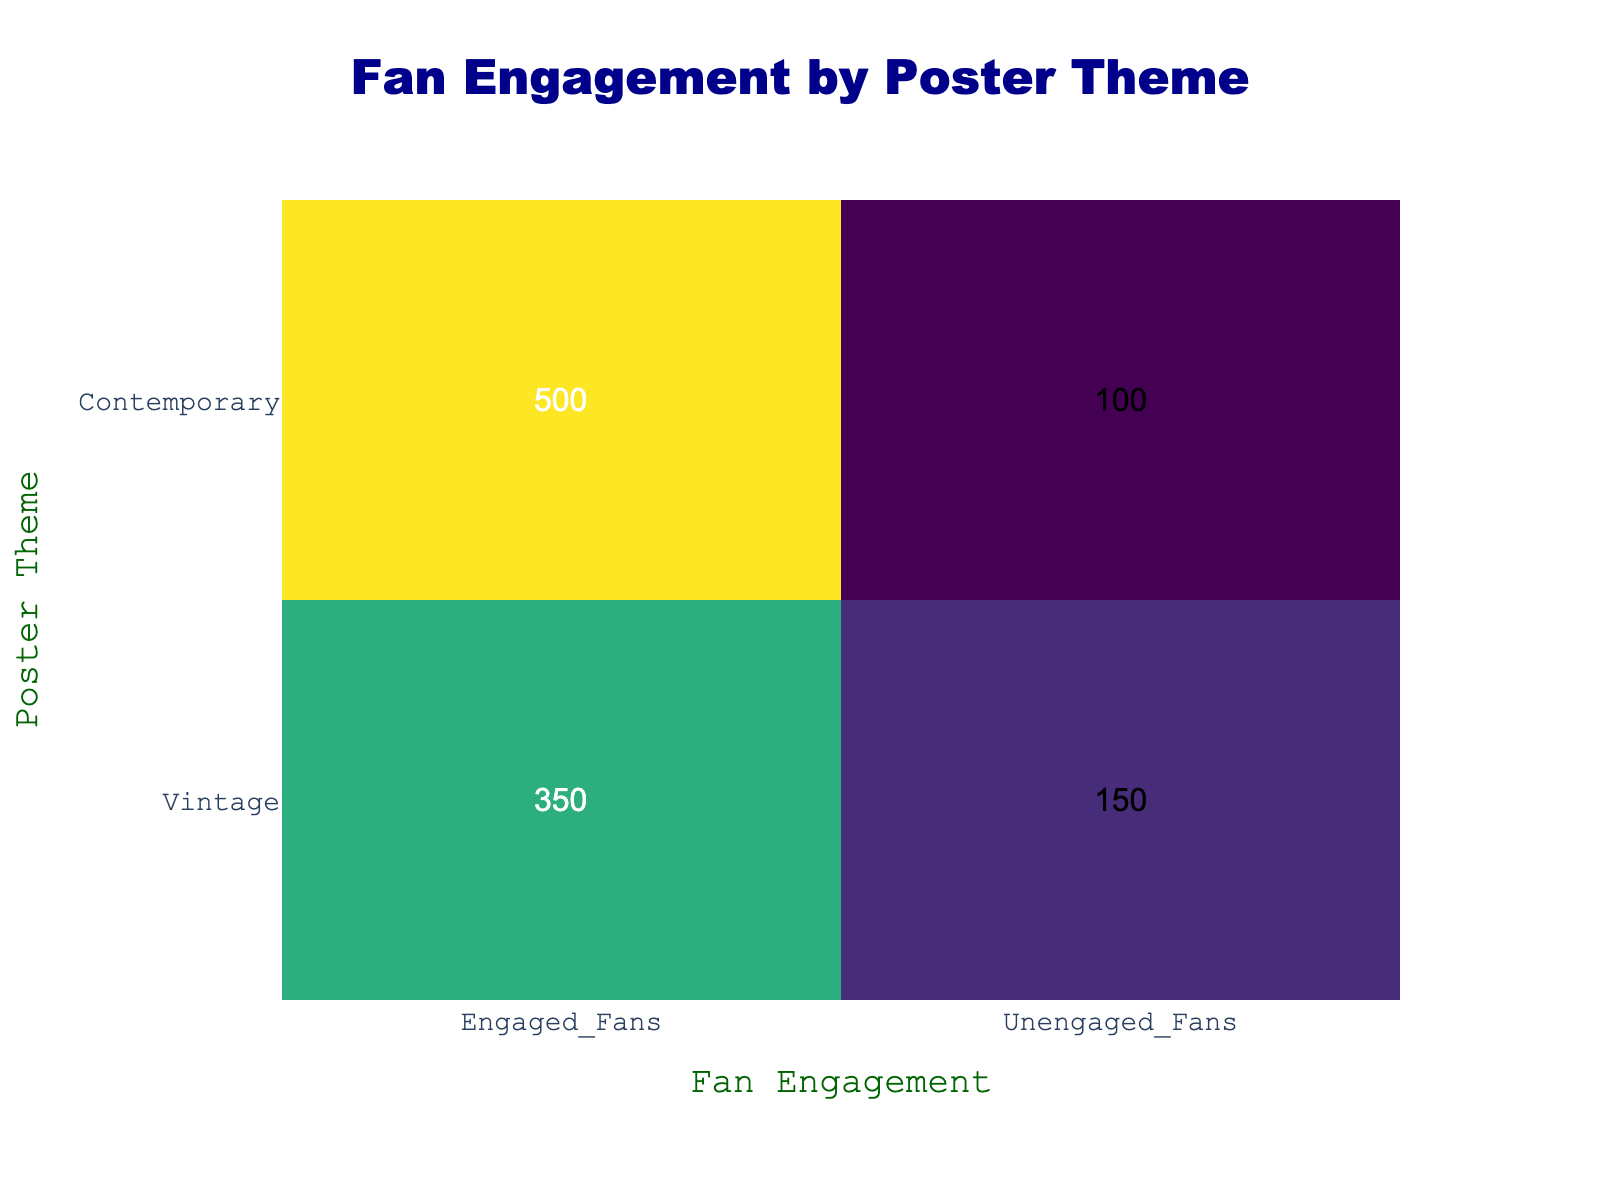What is the number of engaged fans for the contemporary poster theme? According to the table, the value for engaged fans under the contemporary poster theme is directly listed as 500.
Answer: 500 What is the total number of unengaged fans across both poster themes? To find the total, we simply add the unengaged fans for both themes: 150 (vintage) + 100 (contemporary) = 250.
Answer: 250 How many more engaged fans does the contemporary theme have compared to the vintage theme? We can determine the difference by subtracting the number of engaged fans in the vintage theme (350) from those in the contemporary theme (500): 500 - 350 = 150.
Answer: 150 Is it true that the vintage poster theme has a higher number of unengaged fans than the contemporary theme? The table shows that there are 150 unengaged fans for vintage and 100 for contemporary. Since 150 is greater than 100, the statement is true.
Answer: Yes What percentage of fans were engaged in the vintage poster theme? The total number of fans for the vintage theme can be calculated by adding the engaged and unengaged fans: 350 + 150 = 500. The percentage of engaged fans is then (350 engaged fans / 500 total fans) * 100 = 70%.
Answer: 70% If we were to take the average number of engaged fans from both poster themes, what would that average be? First, we add the engaged fans from both themes: 350 (vintage) + 500 (contemporary) = 850. Then, we divide this sum by the number of themes (2): 850 / 2 = 425.
Answer: 425 What is the ratio of engaged fans to unengaged fans for the vintage poster theme? The number of engaged fans for vintage is 350 and unengaged is 150. The ratio is 350:150, which simplifies to 7:3.
Answer: 7:3 Are there more engaged fans in the vintage theme than unengaged fans in the contemporary theme? For the vintage theme, there are 350 engaged fans, while for the contemporary theme, the unengaged fans are 100. Since 350 is greater than 100, this statement is true.
Answer: Yes 